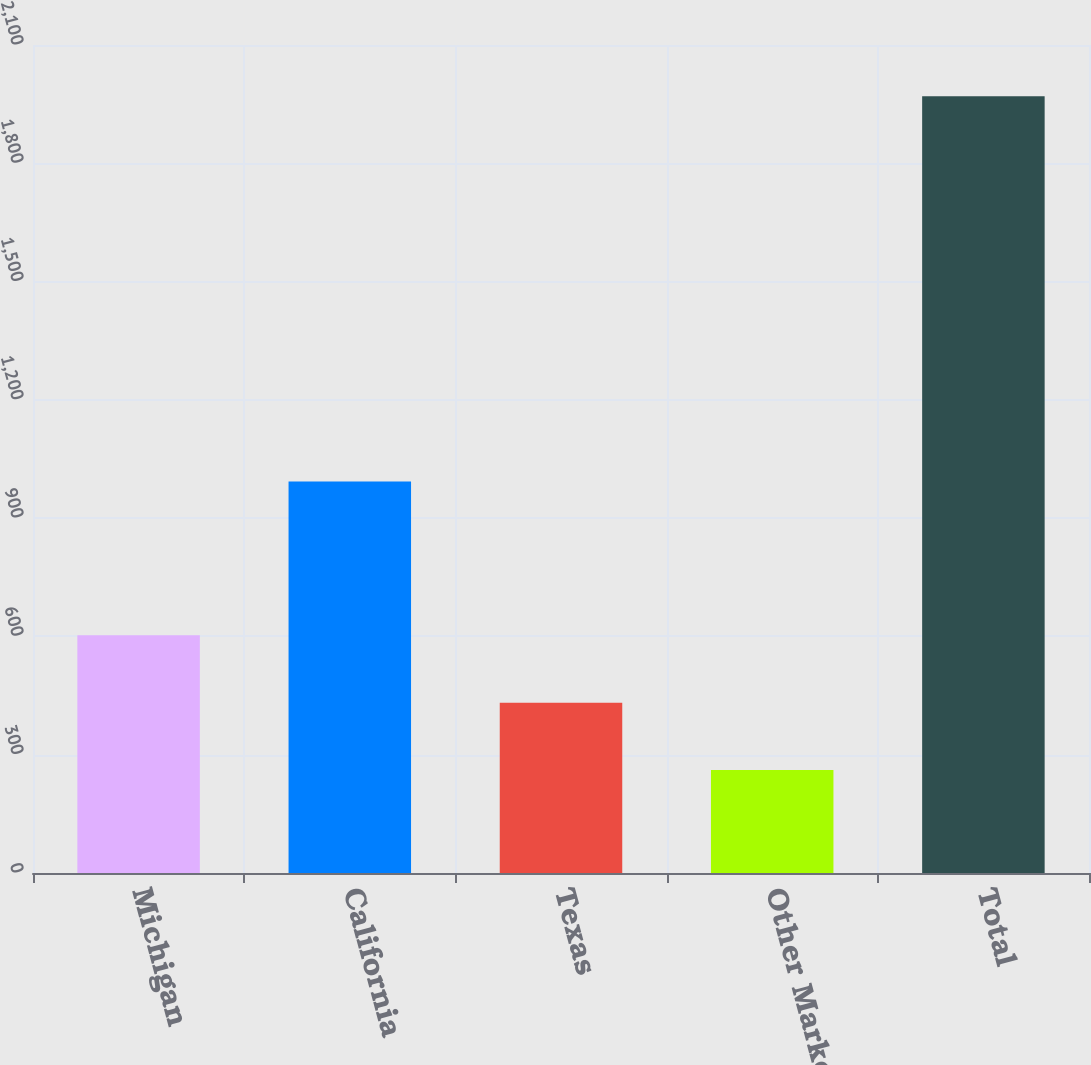Convert chart to OTSL. <chart><loc_0><loc_0><loc_500><loc_500><bar_chart><fcel>Michigan<fcel>California<fcel>Texas<fcel>Other Markets<fcel>Total<nl><fcel>602.8<fcel>993<fcel>431.9<fcel>261<fcel>1970<nl></chart> 